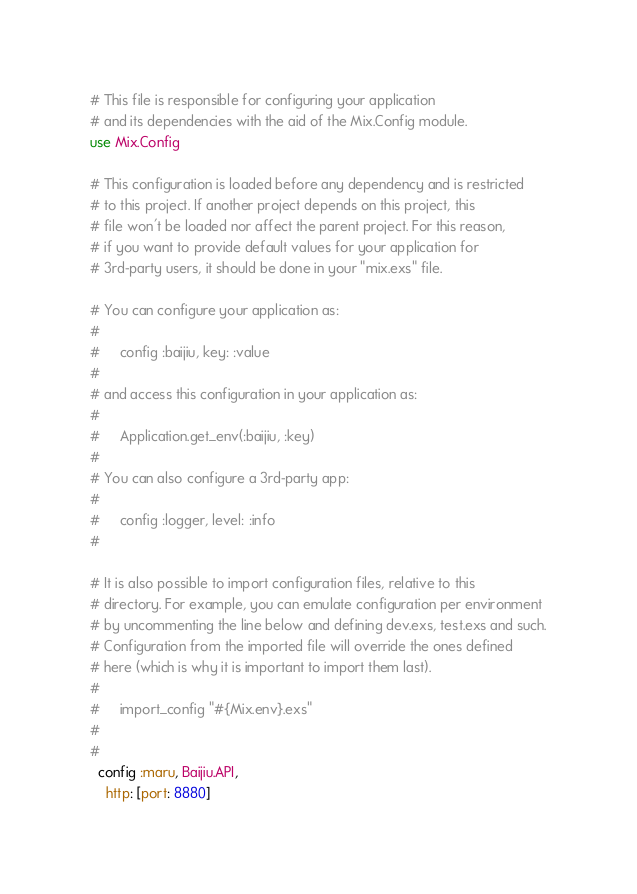Convert code to text. <code><loc_0><loc_0><loc_500><loc_500><_Elixir_># This file is responsible for configuring your application
# and its dependencies with the aid of the Mix.Config module.
use Mix.Config

# This configuration is loaded before any dependency and is restricted
# to this project. If another project depends on this project, this
# file won't be loaded nor affect the parent project. For this reason,
# if you want to provide default values for your application for
# 3rd-party users, it should be done in your "mix.exs" file.

# You can configure your application as:
#
#     config :baijiu, key: :value
#
# and access this configuration in your application as:
#
#     Application.get_env(:baijiu, :key)
#
# You can also configure a 3rd-party app:
#
#     config :logger, level: :info
#

# It is also possible to import configuration files, relative to this
# directory. For example, you can emulate configuration per environment
# by uncommenting the line below and defining dev.exs, test.exs and such.
# Configuration from the imported file will override the ones defined
# here (which is why it is important to import them last).
#
#     import_config "#{Mix.env}.exs"
#
#
  config :maru, Baijiu.API,
    http: [port: 8880]
</code> 